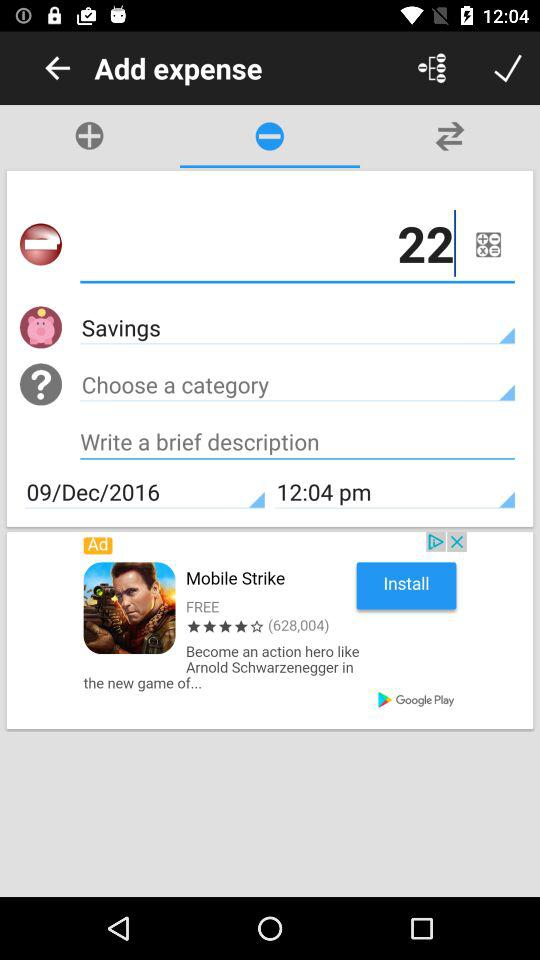What is the date of the expense?
Answer the question using a single word or phrase. 09/Dec/2016 